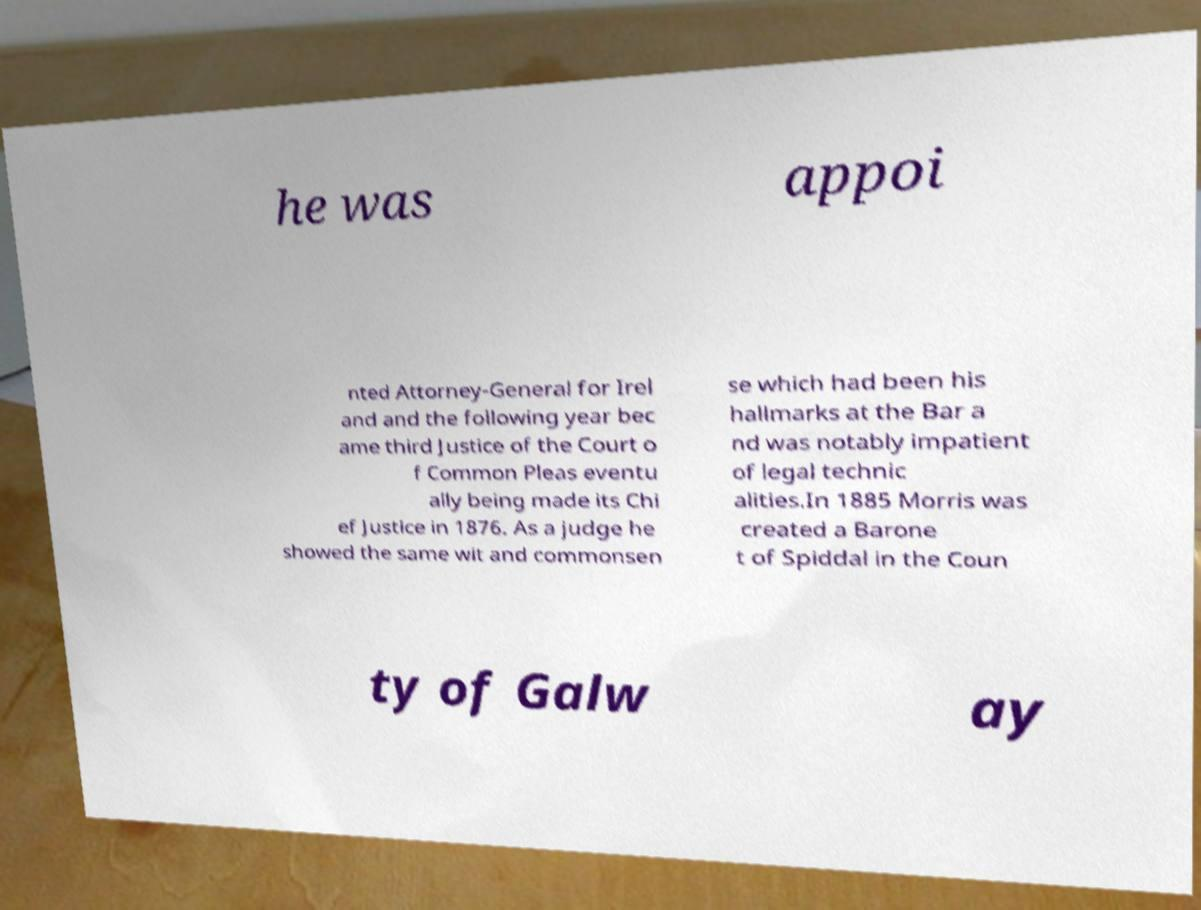Please read and relay the text visible in this image. What does it say? he was appoi nted Attorney-General for Irel and and the following year bec ame third Justice of the Court o f Common Pleas eventu ally being made its Chi ef Justice in 1876. As a judge he showed the same wit and commonsen se which had been his hallmarks at the Bar a nd was notably impatient of legal technic alities.In 1885 Morris was created a Barone t of Spiddal in the Coun ty of Galw ay 